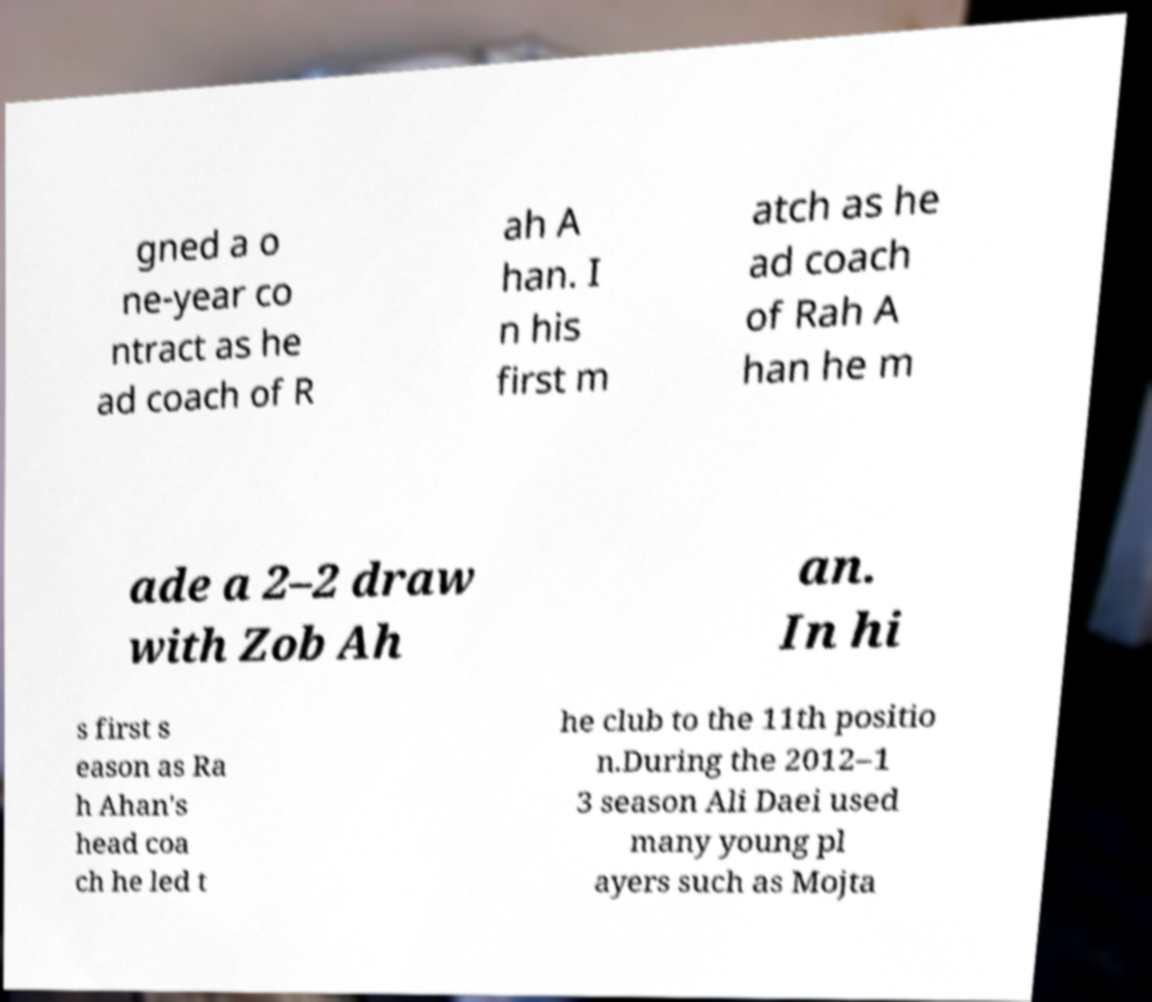For documentation purposes, I need the text within this image transcribed. Could you provide that? gned a o ne-year co ntract as he ad coach of R ah A han. I n his first m atch as he ad coach of Rah A han he m ade a 2–2 draw with Zob Ah an. In hi s first s eason as Ra h Ahan's head coa ch he led t he club to the 11th positio n.During the 2012–1 3 season Ali Daei used many young pl ayers such as Mojta 